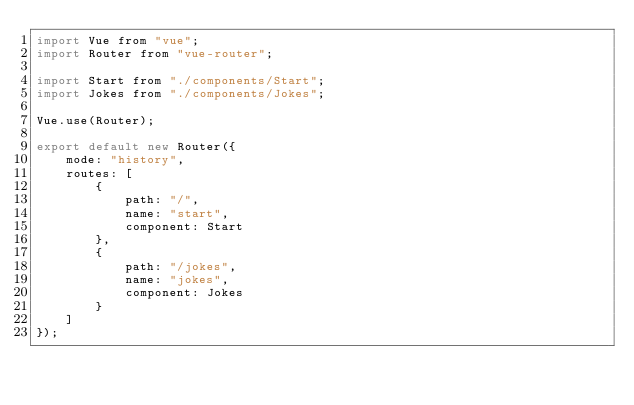<code> <loc_0><loc_0><loc_500><loc_500><_JavaScript_>import Vue from "vue";
import Router from "vue-router";

import Start from "./components/Start";
import Jokes from "./components/Jokes";

Vue.use(Router);

export default new Router({
    mode: "history",
    routes: [
        {
            path: "/",
            name: "start",
            component: Start
        },
        {
            path: "/jokes",
            name: "jokes",
            component: Jokes
        }
    ]
});</code> 